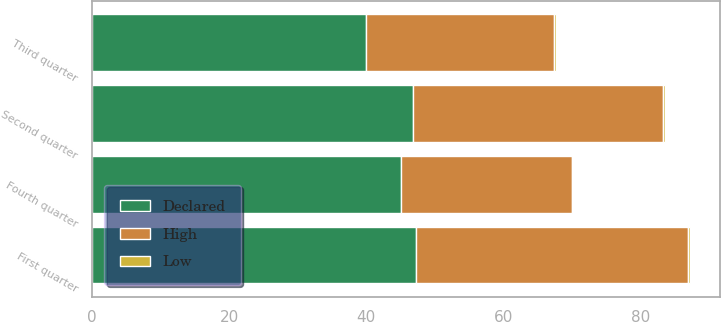<chart> <loc_0><loc_0><loc_500><loc_500><stacked_bar_chart><ecel><fcel>First quarter<fcel>Second quarter<fcel>Third quarter<fcel>Fourth quarter<nl><fcel>Declared<fcel>47.18<fcel>46.8<fcel>39.99<fcel>45<nl><fcel>High<fcel>39.77<fcel>36.51<fcel>27.44<fcel>25.06<nl><fcel>Low<fcel>0.25<fcel>0.25<fcel>0.25<fcel>0.01<nl></chart> 